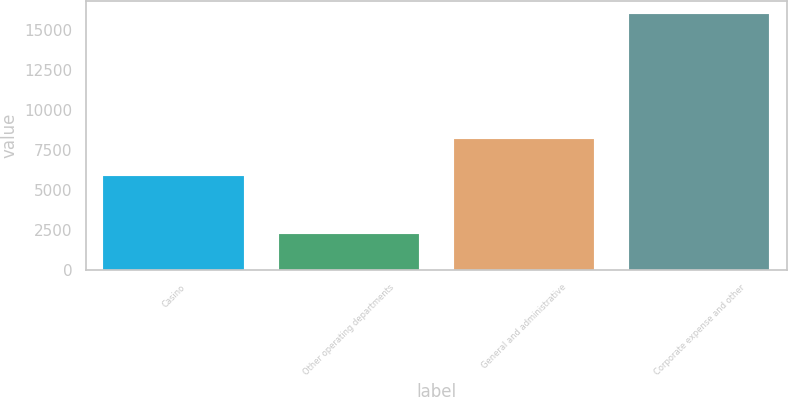Convert chart. <chart><loc_0><loc_0><loc_500><loc_500><bar_chart><fcel>Casino<fcel>Other operating departments<fcel>General and administrative<fcel>Corporate expense and other<nl><fcel>5879<fcel>2241<fcel>8176<fcel>16036<nl></chart> 